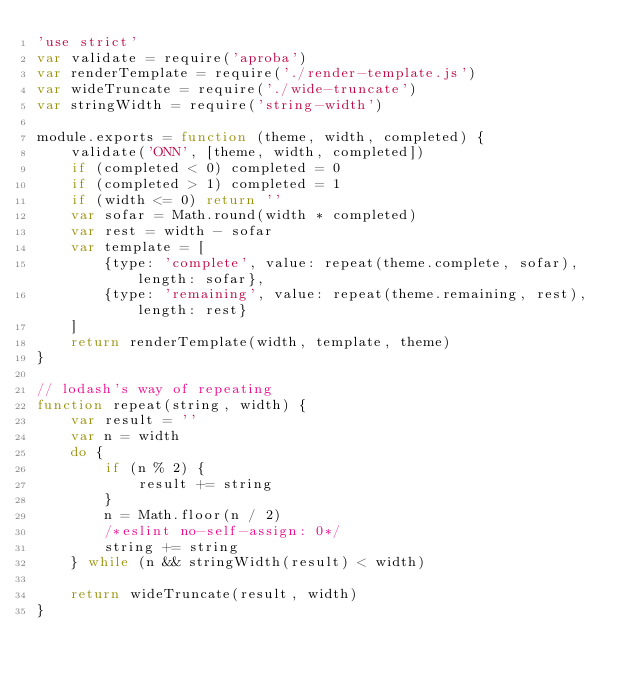<code> <loc_0><loc_0><loc_500><loc_500><_JavaScript_>'use strict'
var validate = require('aproba')
var renderTemplate = require('./render-template.js')
var wideTruncate = require('./wide-truncate')
var stringWidth = require('string-width')

module.exports = function (theme, width, completed) {
    validate('ONN', [theme, width, completed])
    if (completed < 0) completed = 0
    if (completed > 1) completed = 1
    if (width <= 0) return ''
    var sofar = Math.round(width * completed)
    var rest = width - sofar
    var template = [
        {type: 'complete', value: repeat(theme.complete, sofar), length: sofar},
        {type: 'remaining', value: repeat(theme.remaining, rest), length: rest}
    ]
    return renderTemplate(width, template, theme)
}

// lodash's way of repeating
function repeat(string, width) {
    var result = ''
    var n = width
    do {
        if (n % 2) {
            result += string
        }
        n = Math.floor(n / 2)
        /*eslint no-self-assign: 0*/
        string += string
    } while (n && stringWidth(result) < width)

    return wideTruncate(result, width)
}
</code> 